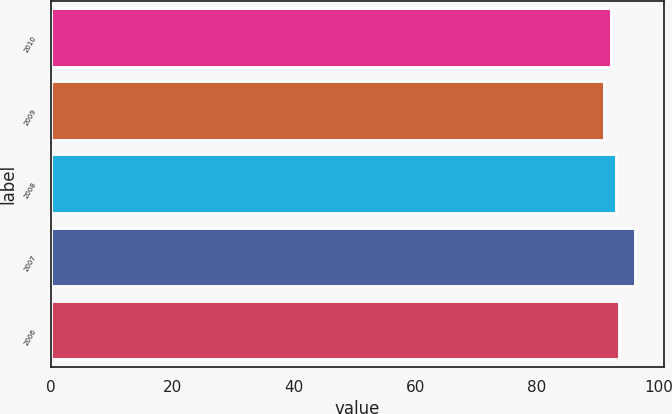Convert chart. <chart><loc_0><loc_0><loc_500><loc_500><bar_chart><fcel>2010<fcel>2009<fcel>2008<fcel>2007<fcel>2006<nl><fcel>92.2<fcel>91.1<fcel>93<fcel>96.1<fcel>93.5<nl></chart> 